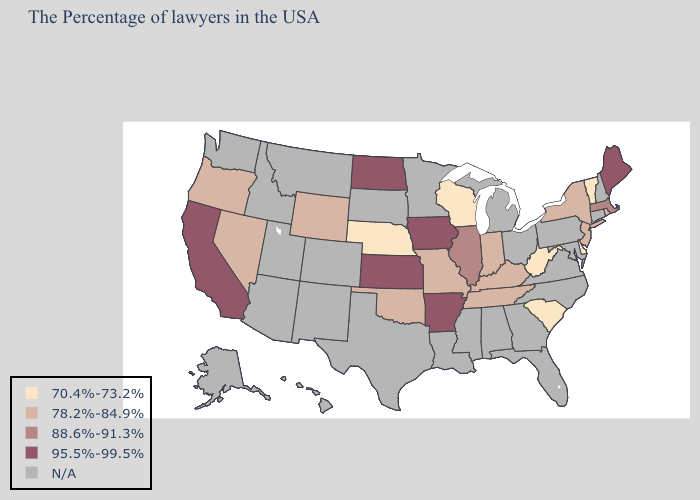Which states have the highest value in the USA?
Short answer required. Maine, Arkansas, Iowa, Kansas, North Dakota, California. What is the lowest value in states that border Georgia?
Concise answer only. 70.4%-73.2%. What is the value of Arizona?
Quick response, please. N/A. Which states have the highest value in the USA?
Short answer required. Maine, Arkansas, Iowa, Kansas, North Dakota, California. Name the states that have a value in the range 88.6%-91.3%?
Answer briefly. Massachusetts, Illinois. What is the value of Utah?
Short answer required. N/A. Which states hav the highest value in the South?
Answer briefly. Arkansas. Does the first symbol in the legend represent the smallest category?
Keep it brief. Yes. Name the states that have a value in the range 70.4%-73.2%?
Concise answer only. Vermont, Delaware, South Carolina, West Virginia, Wisconsin, Nebraska. What is the value of Texas?
Write a very short answer. N/A. What is the highest value in the MidWest ?
Answer briefly. 95.5%-99.5%. What is the highest value in the USA?
Quick response, please. 95.5%-99.5%. Name the states that have a value in the range 88.6%-91.3%?
Quick response, please. Massachusetts, Illinois. 